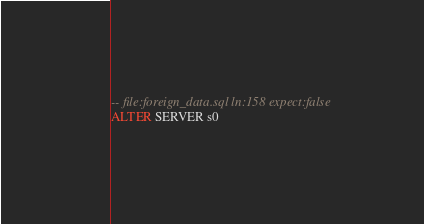<code> <loc_0><loc_0><loc_500><loc_500><_SQL_>-- file:foreign_data.sql ln:158 expect:false
ALTER SERVER s0
</code> 